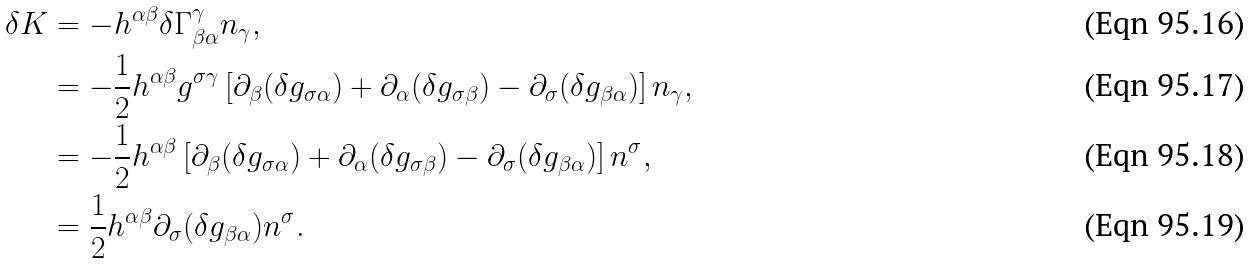Convert formula to latex. <formula><loc_0><loc_0><loc_500><loc_500>\delta K & = - h ^ { \alpha \beta } \delta \Gamma _ { \beta \alpha } ^ { \gamma } n _ { \gamma } , \\ & = - \frac { 1 } { 2 } h ^ { \alpha \beta } g ^ { \sigma \gamma } \left [ \partial _ { \beta } ( \delta g _ { \sigma \alpha } ) + \partial _ { \alpha } ( \delta g _ { \sigma \beta } ) - \partial _ { \sigma } ( \delta g _ { \beta \alpha } ) \right ] n _ { \gamma } , \\ & = - \frac { 1 } { 2 } h ^ { \alpha \beta } \left [ \partial _ { \beta } ( \delta g _ { \sigma \alpha } ) + \partial _ { \alpha } ( \delta g _ { \sigma \beta } ) - \partial _ { \sigma } ( \delta g _ { \beta \alpha } ) \right ] n ^ { \sigma } , \\ & = \frac { 1 } { 2 } h ^ { \alpha \beta } \partial _ { \sigma } ( \delta g _ { \beta \alpha } ) n ^ { \sigma } .</formula> 